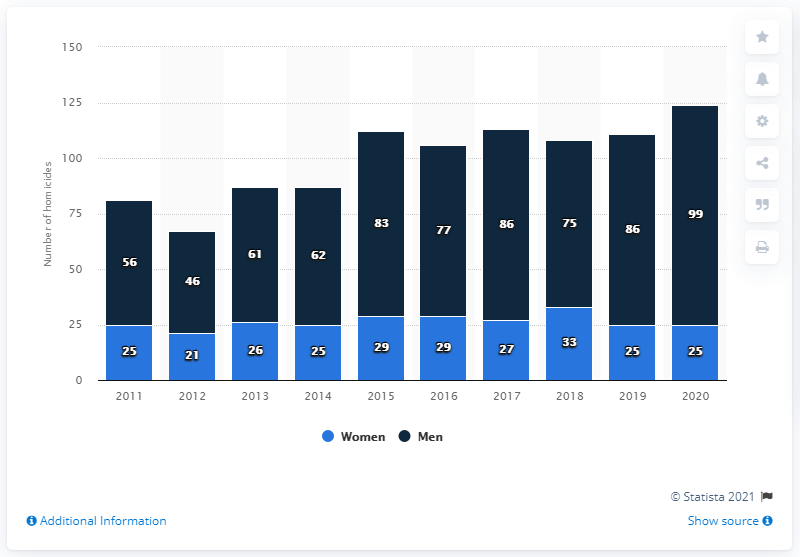Outline some significant characteristics in this image. In 2020, a total of 99 men and 25 women were confirmed as homicide victims in Sweden. 